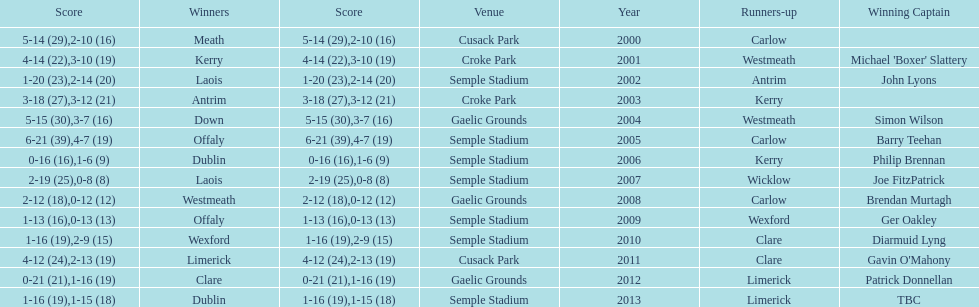Who was the initial victor in 2013? Dublin. 